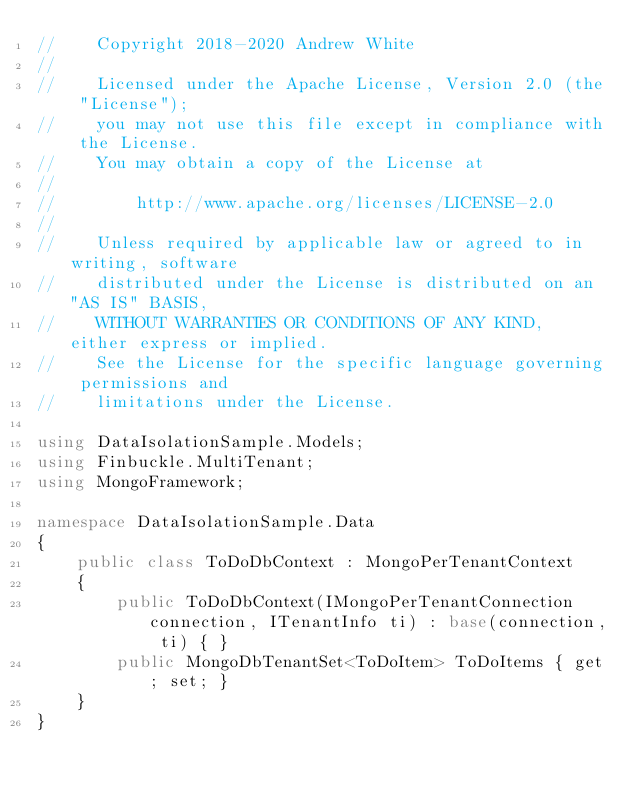Convert code to text. <code><loc_0><loc_0><loc_500><loc_500><_C#_>//    Copyright 2018-2020 Andrew White
//
//    Licensed under the Apache License, Version 2.0 (the "License");
//    you may not use this file except in compliance with the License.
//    You may obtain a copy of the License at
//
//        http://www.apache.org/licenses/LICENSE-2.0
//
//    Unless required by applicable law or agreed to in writing, software
//    distributed under the License is distributed on an "AS IS" BASIS,
//    WITHOUT WARRANTIES OR CONDITIONS OF ANY KIND, either express or implied.
//    See the License for the specific language governing permissions and
//    limitations under the License.

using DataIsolationSample.Models;
using Finbuckle.MultiTenant;
using MongoFramework;

namespace DataIsolationSample.Data
{
    public class ToDoDbContext : MongoPerTenantContext
    {
        public ToDoDbContext(IMongoPerTenantConnection connection, ITenantInfo ti) : base(connection, ti) { }
        public MongoDbTenantSet<ToDoItem> ToDoItems { get; set; }
    }
}
</code> 